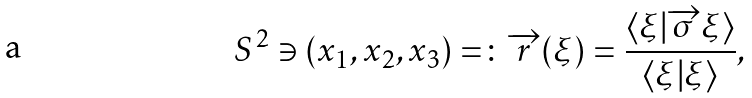Convert formula to latex. <formula><loc_0><loc_0><loc_500><loc_500>S ^ { 2 } \ni ( x _ { 1 } , x _ { 2 } , x _ { 3 } ) = \colon \overrightarrow { r } ( \xi ) = \frac { \langle \xi | \overrightarrow { \sigma } \xi \rangle } { \langle \xi | \xi \rangle } ,</formula> 